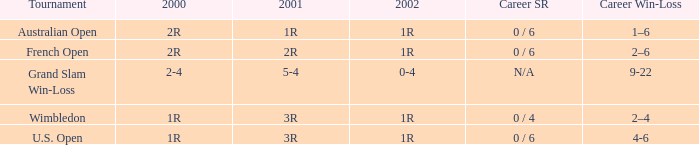Which career win-loss record has a 1r in 2002, a 2r in 2000 and a 2r in 2001? 2–6. 